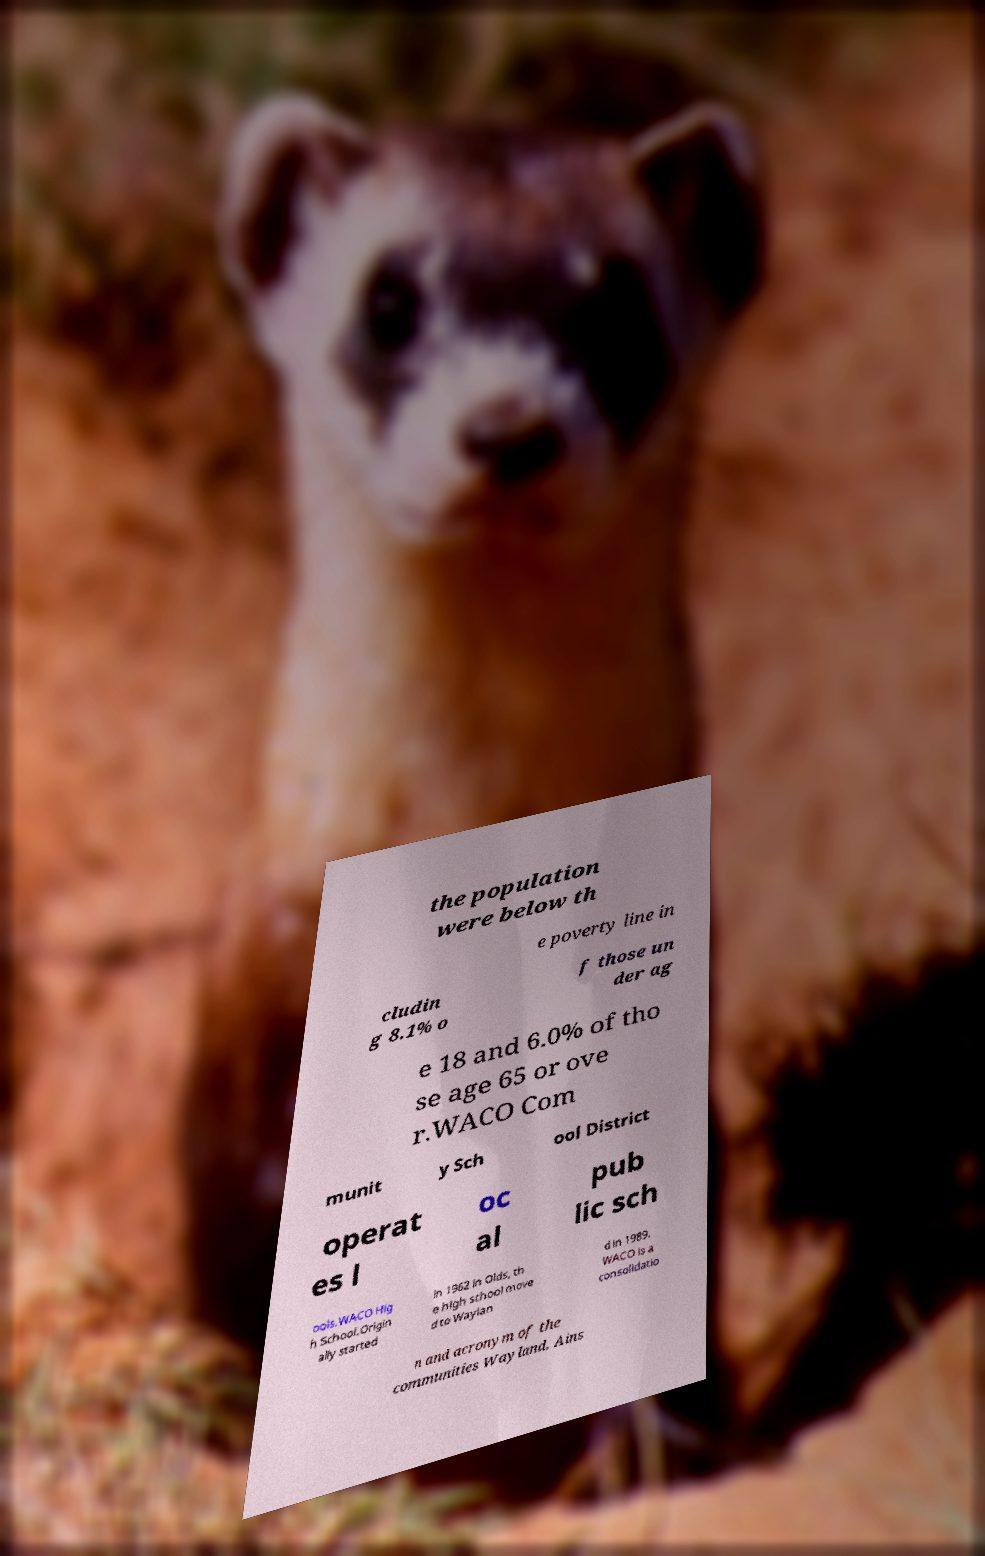There's text embedded in this image that I need extracted. Can you transcribe it verbatim? the population were below th e poverty line in cludin g 8.1% o f those un der ag e 18 and 6.0% of tho se age 65 or ove r.WACO Com munit y Sch ool District operat es l oc al pub lic sch ools.WACO Hig h School.Origin ally started in 1962 in Olds, th e high school move d to Waylan d in 1989. WACO is a consolidatio n and acronym of the communities Wayland, Ains 